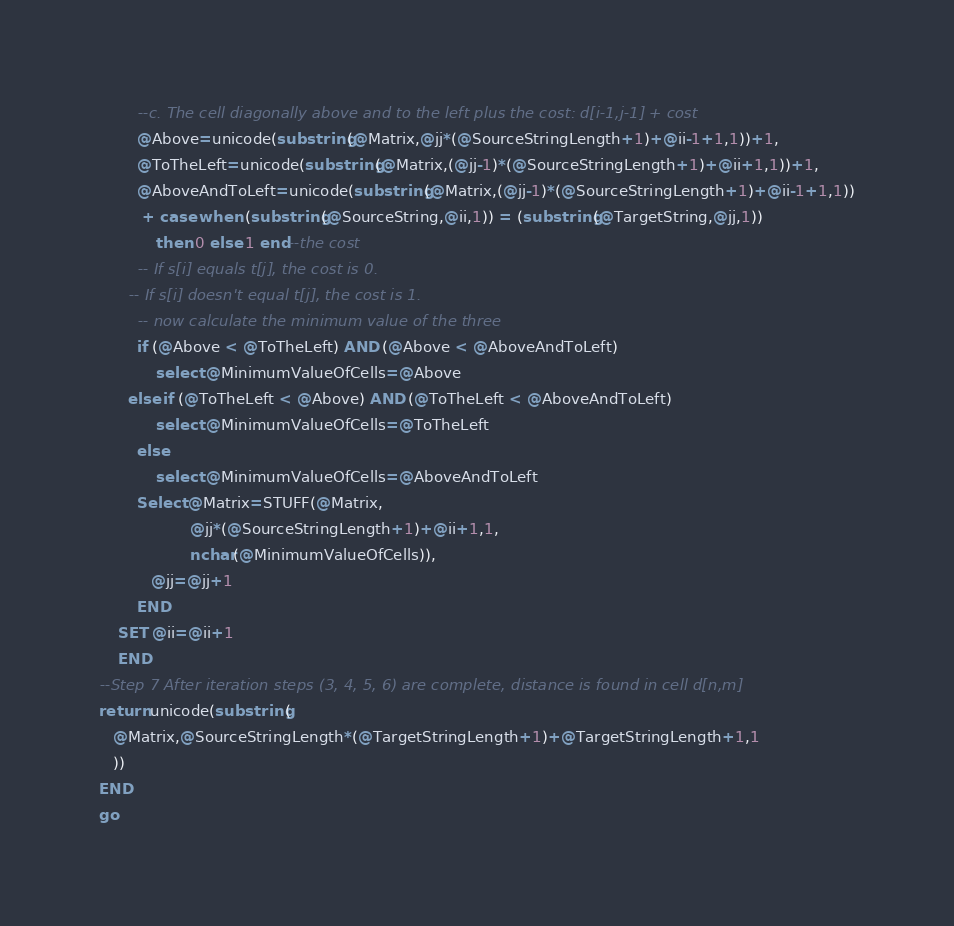<code> <loc_0><loc_0><loc_500><loc_500><_SQL_>        --c. The cell diagonally above and to the left plus the cost: d[i-1,j-1] + cost
        @Above=unicode(substring(@Matrix,@jj*(@SourceStringLength+1)+@ii-1+1,1))+1,
        @ToTheLeft=unicode(substring(@Matrix,(@jj-1)*(@SourceStringLength+1)+@ii+1,1))+1,
        @AboveAndToLeft=unicode(substring(@Matrix,(@jj-1)*(@SourceStringLength+1)+@ii-1+1,1))
         + case when (substring(@SourceString,@ii,1)) = (substring(@TargetString,@jj,1)) 
            then 0 else 1 end--the cost
        -- If s[i] equals t[j], the cost is 0.
      -- If s[i] doesn't equal t[j], the cost is 1.
        -- now calculate the minimum value of the three
        if (@Above < @ToTheLeft) AND (@Above < @AboveAndToLeft) 
            select @MinimumValueOfCells=@Above
      else if (@ToTheLeft < @Above) AND (@ToTheLeft < @AboveAndToLeft)
            select @MinimumValueOfCells=@ToTheLeft
        else
            select @MinimumValueOfCells=@AboveAndToLeft
        Select @Matrix=STUFF(@Matrix,
                   @jj*(@SourceStringLength+1)+@ii+1,1,
                   nchar(@MinimumValueOfCells)),
           @jj=@jj+1
        END
    SET @ii=@ii+1
    END    
--Step 7 After iteration steps (3, 4, 5, 6) are complete, distance is found in cell d[n,m]
return unicode(substring(
   @Matrix,@SourceStringLength*(@TargetStringLength+1)+@TargetStringLength+1,1
   ))
END
go</code> 